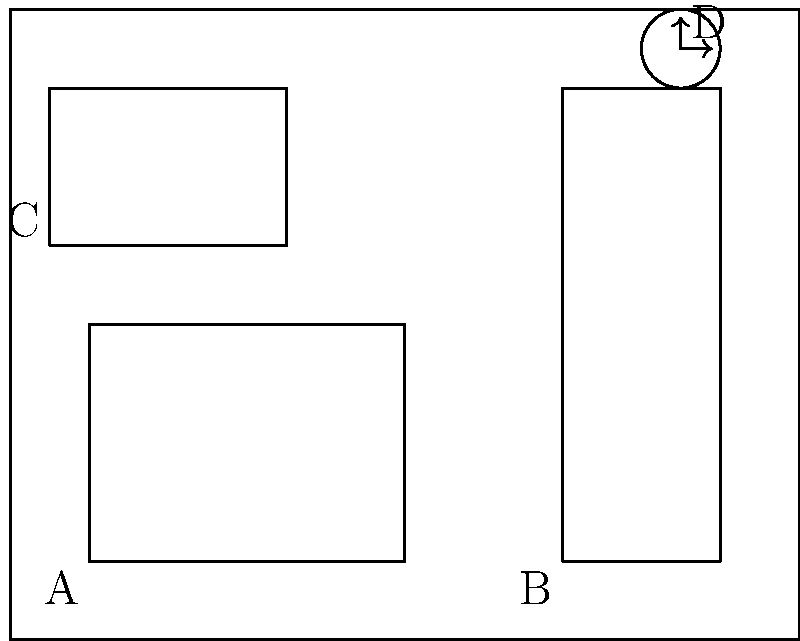In this illustration of a child's bedroom, identify how many right angles are present in the labeled objects (A, B, C, and D). Consider the corners of the bed, bookshelf, window, and the hands of the clock. How can understanding right angles in everyday objects help children develop spatial awareness and geometric thinking skills? Let's analyze each labeled object in the child's bedroom scene:

1. Object A (Bed):
   - The bed has four corners, each forming a right angle (90 degrees).
   - Total right angles: 4

2. Object B (Bookshelf):
   - The bookshelf has four corners, each forming a right angle.
   - Total right angles: 4

3. Object C (Window):
   - The window has four corners, each forming a right angle.
   - Total right angles: 4

4. Object D (Clock):
   - The clock hands are positioned at 3:00, forming a right angle between them.
   - Total right angles: 1

To calculate the total number of right angles:
$$ \text{Total right angles} = 4 + 4 + 4 + 1 = 13 $$

Understanding right angles in everyday objects can help children develop spatial awareness and geometric thinking skills in several ways:

1. Recognition of shapes: Children learn to identify and categorize objects based on their geometric properties.
2. Spatial relationships: Understanding right angles helps children comprehend how objects fit together and relate to each other in space.
3. Problem-solving: Recognizing right angles can aid in tasks like furniture arrangement or building with blocks.
4. Mathematical foundations: This knowledge forms the basis for more advanced geometric concepts and measurements.
5. Real-world applications: Children can connect abstract mathematical concepts to tangible objects in their environment.

By incorporating storytelling and play-based activities centered around identifying right angles in familiar settings, child psychologists can help children develop these important cognitive skills in an engaging and relatable manner.
Answer: 13 right angles 